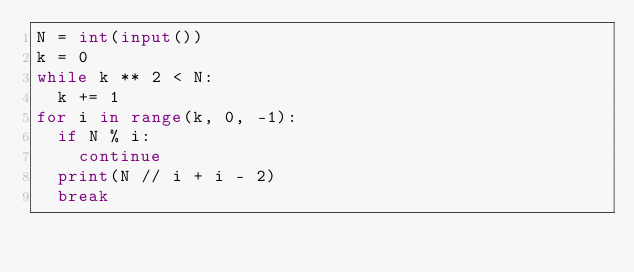<code> <loc_0><loc_0><loc_500><loc_500><_Python_>N = int(input())
k = 0
while k ** 2 < N:
  k += 1
for i in range(k, 0, -1):
  if N % i:
    continue
  print(N // i + i - 2)
  break</code> 